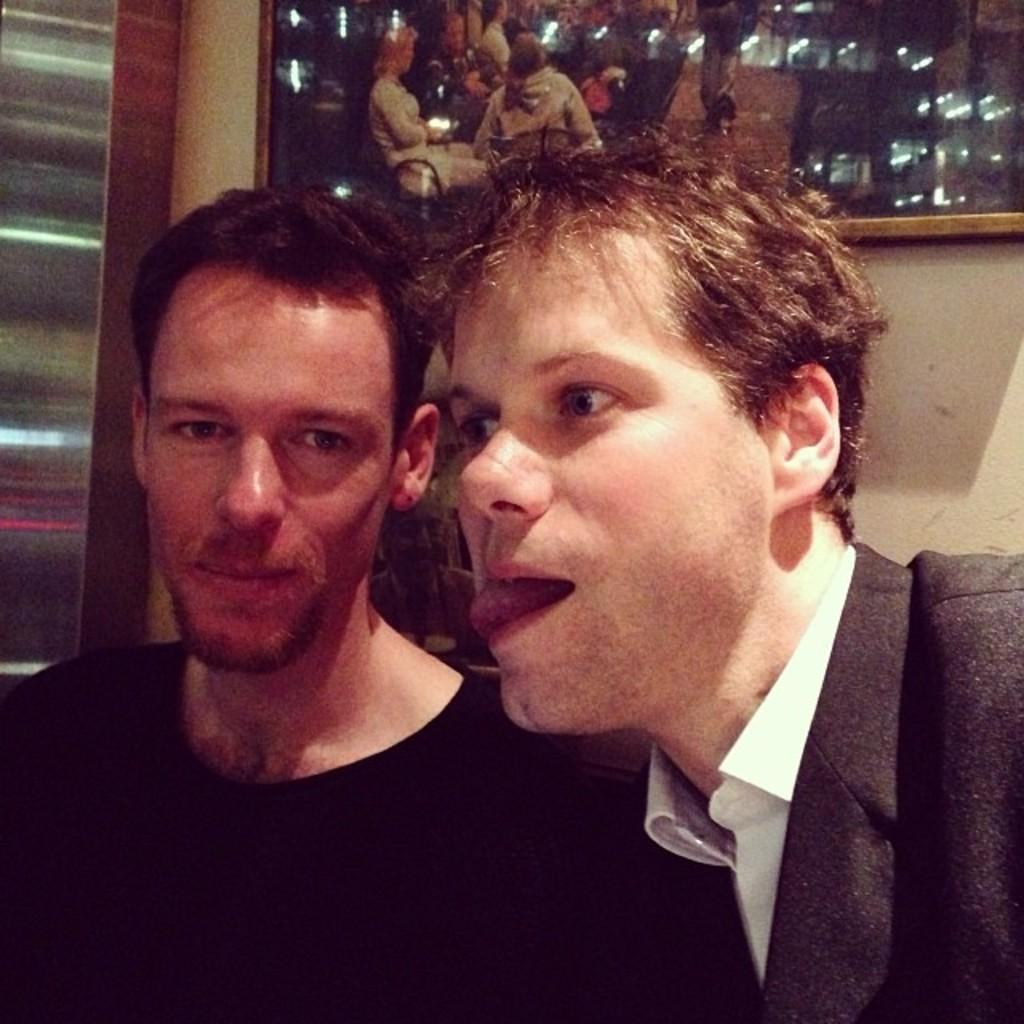How many people are present in the image? There are two persons in the image. Can you describe any objects or features in the background? There is a mirror on a wall in the image. What type of ocean can be seen in the image? There is no ocean present in the image. 